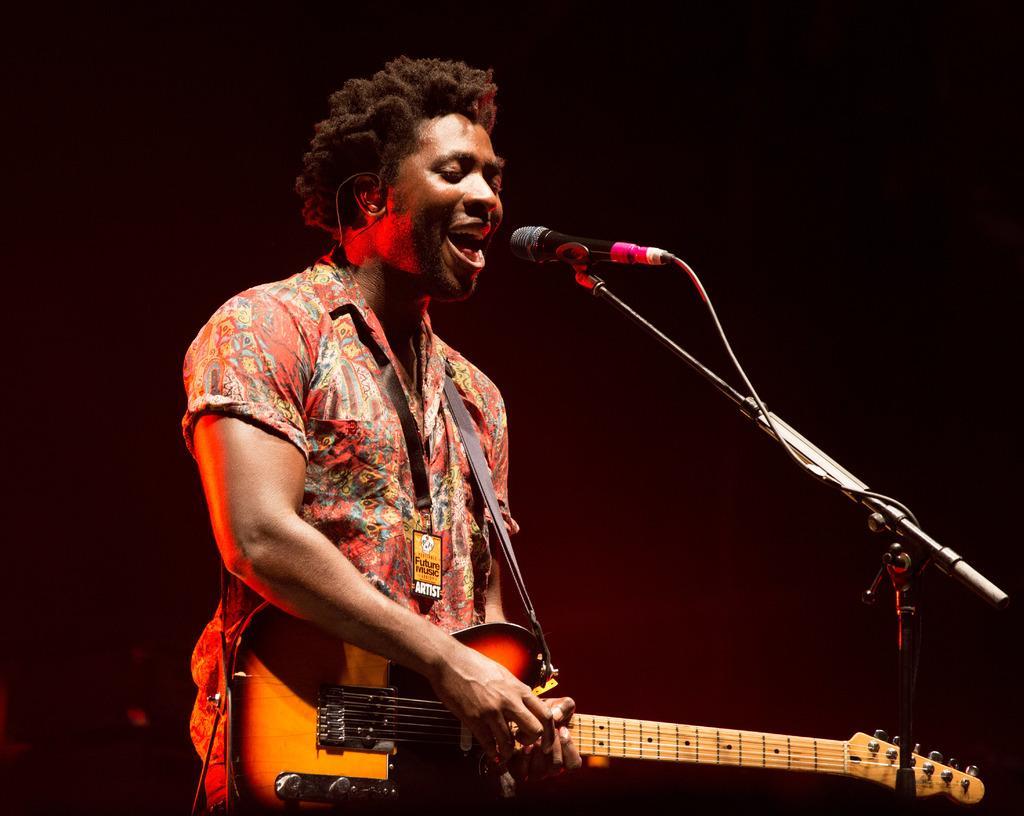Describe this image in one or two sentences. A man is standing, he is playing guitar. He is singing because his mouth is opened. There is a microphone in front of him. Background is dark. 